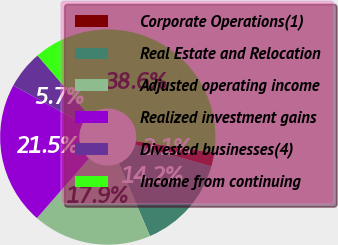<chart> <loc_0><loc_0><loc_500><loc_500><pie_chart><fcel>Corporate Operations(1)<fcel>Real Estate and Relocation<fcel>Adjusted operating income<fcel>Realized investment gains<fcel>Divested businesses(4)<fcel>Income from continuing<nl><fcel>2.08%<fcel>14.2%<fcel>17.85%<fcel>21.51%<fcel>5.74%<fcel>38.62%<nl></chart> 